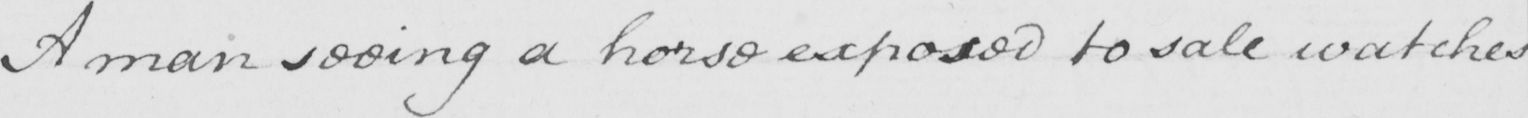Can you tell me what this handwritten text says? A man seeing a horse exposed to sale watches 